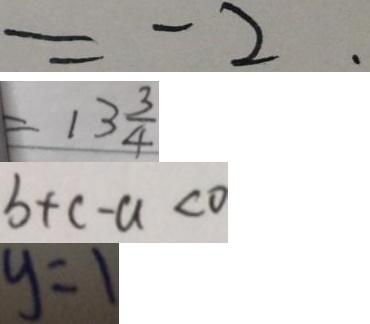Convert formula to latex. <formula><loc_0><loc_0><loc_500><loc_500>= - 2 . 
 = 1 3 \frac { 3 } { 4 } 
 b + c - a < 0 
 y = 1</formula> 